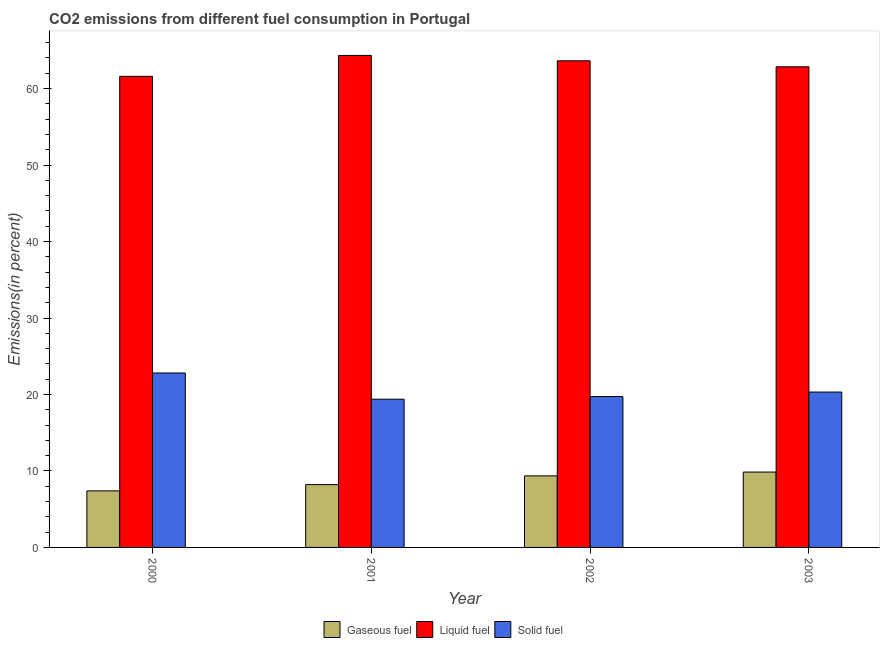How many groups of bars are there?
Offer a very short reply. 4. Are the number of bars per tick equal to the number of legend labels?
Your answer should be very brief. Yes. How many bars are there on the 3rd tick from the left?
Your answer should be compact. 3. In how many cases, is the number of bars for a given year not equal to the number of legend labels?
Your answer should be very brief. 0. What is the percentage of gaseous fuel emission in 2000?
Offer a terse response. 7.4. Across all years, what is the maximum percentage of liquid fuel emission?
Your answer should be very brief. 64.34. Across all years, what is the minimum percentage of liquid fuel emission?
Give a very brief answer. 61.6. What is the total percentage of solid fuel emission in the graph?
Give a very brief answer. 82.24. What is the difference between the percentage of gaseous fuel emission in 2001 and that in 2003?
Give a very brief answer. -1.64. What is the difference between the percentage of gaseous fuel emission in 2001 and the percentage of liquid fuel emission in 2002?
Your answer should be compact. -1.14. What is the average percentage of liquid fuel emission per year?
Provide a succinct answer. 63.1. In how many years, is the percentage of gaseous fuel emission greater than 28 %?
Provide a short and direct response. 0. What is the ratio of the percentage of gaseous fuel emission in 2001 to that in 2003?
Your answer should be very brief. 0.83. What is the difference between the highest and the second highest percentage of gaseous fuel emission?
Provide a short and direct response. 0.5. What is the difference between the highest and the lowest percentage of liquid fuel emission?
Your answer should be very brief. 2.74. Is the sum of the percentage of liquid fuel emission in 2000 and 2003 greater than the maximum percentage of gaseous fuel emission across all years?
Your answer should be very brief. Yes. What does the 3rd bar from the left in 2001 represents?
Offer a terse response. Solid fuel. What does the 1st bar from the right in 2002 represents?
Give a very brief answer. Solid fuel. Is it the case that in every year, the sum of the percentage of gaseous fuel emission and percentage of liquid fuel emission is greater than the percentage of solid fuel emission?
Your answer should be compact. Yes. How many bars are there?
Your response must be concise. 12. Are all the bars in the graph horizontal?
Offer a terse response. No. How many years are there in the graph?
Your answer should be very brief. 4. How are the legend labels stacked?
Offer a terse response. Horizontal. What is the title of the graph?
Your answer should be compact. CO2 emissions from different fuel consumption in Portugal. What is the label or title of the X-axis?
Your answer should be very brief. Year. What is the label or title of the Y-axis?
Provide a succinct answer. Emissions(in percent). What is the Emissions(in percent) of Gaseous fuel in 2000?
Give a very brief answer. 7.4. What is the Emissions(in percent) in Liquid fuel in 2000?
Offer a terse response. 61.6. What is the Emissions(in percent) of Solid fuel in 2000?
Ensure brevity in your answer.  22.81. What is the Emissions(in percent) in Gaseous fuel in 2001?
Give a very brief answer. 8.21. What is the Emissions(in percent) of Liquid fuel in 2001?
Ensure brevity in your answer.  64.34. What is the Emissions(in percent) of Solid fuel in 2001?
Make the answer very short. 19.38. What is the Emissions(in percent) in Gaseous fuel in 2002?
Your answer should be very brief. 9.36. What is the Emissions(in percent) of Liquid fuel in 2002?
Provide a succinct answer. 63.63. What is the Emissions(in percent) of Solid fuel in 2002?
Provide a short and direct response. 19.73. What is the Emissions(in percent) in Gaseous fuel in 2003?
Your answer should be compact. 9.86. What is the Emissions(in percent) in Liquid fuel in 2003?
Ensure brevity in your answer.  62.85. What is the Emissions(in percent) of Solid fuel in 2003?
Your response must be concise. 20.32. Across all years, what is the maximum Emissions(in percent) of Gaseous fuel?
Provide a succinct answer. 9.86. Across all years, what is the maximum Emissions(in percent) in Liquid fuel?
Give a very brief answer. 64.34. Across all years, what is the maximum Emissions(in percent) of Solid fuel?
Provide a short and direct response. 22.81. Across all years, what is the minimum Emissions(in percent) in Gaseous fuel?
Your answer should be compact. 7.4. Across all years, what is the minimum Emissions(in percent) of Liquid fuel?
Your answer should be compact. 61.6. Across all years, what is the minimum Emissions(in percent) of Solid fuel?
Keep it short and to the point. 19.38. What is the total Emissions(in percent) of Gaseous fuel in the graph?
Ensure brevity in your answer.  34.82. What is the total Emissions(in percent) in Liquid fuel in the graph?
Offer a very short reply. 252.41. What is the total Emissions(in percent) of Solid fuel in the graph?
Provide a short and direct response. 82.24. What is the difference between the Emissions(in percent) in Gaseous fuel in 2000 and that in 2001?
Provide a succinct answer. -0.82. What is the difference between the Emissions(in percent) in Liquid fuel in 2000 and that in 2001?
Offer a very short reply. -2.74. What is the difference between the Emissions(in percent) in Solid fuel in 2000 and that in 2001?
Give a very brief answer. 3.43. What is the difference between the Emissions(in percent) of Gaseous fuel in 2000 and that in 2002?
Keep it short and to the point. -1.96. What is the difference between the Emissions(in percent) of Liquid fuel in 2000 and that in 2002?
Provide a short and direct response. -2.03. What is the difference between the Emissions(in percent) in Solid fuel in 2000 and that in 2002?
Offer a very short reply. 3.08. What is the difference between the Emissions(in percent) in Gaseous fuel in 2000 and that in 2003?
Offer a terse response. -2.46. What is the difference between the Emissions(in percent) of Liquid fuel in 2000 and that in 2003?
Provide a succinct answer. -1.25. What is the difference between the Emissions(in percent) of Solid fuel in 2000 and that in 2003?
Offer a very short reply. 2.49. What is the difference between the Emissions(in percent) of Gaseous fuel in 2001 and that in 2002?
Give a very brief answer. -1.14. What is the difference between the Emissions(in percent) of Liquid fuel in 2001 and that in 2002?
Offer a terse response. 0.7. What is the difference between the Emissions(in percent) in Solid fuel in 2001 and that in 2002?
Make the answer very short. -0.34. What is the difference between the Emissions(in percent) of Gaseous fuel in 2001 and that in 2003?
Your answer should be compact. -1.64. What is the difference between the Emissions(in percent) of Liquid fuel in 2001 and that in 2003?
Make the answer very short. 1.49. What is the difference between the Emissions(in percent) of Solid fuel in 2001 and that in 2003?
Give a very brief answer. -0.93. What is the difference between the Emissions(in percent) in Gaseous fuel in 2002 and that in 2003?
Ensure brevity in your answer.  -0.5. What is the difference between the Emissions(in percent) in Liquid fuel in 2002 and that in 2003?
Ensure brevity in your answer.  0.78. What is the difference between the Emissions(in percent) of Solid fuel in 2002 and that in 2003?
Provide a succinct answer. -0.59. What is the difference between the Emissions(in percent) of Gaseous fuel in 2000 and the Emissions(in percent) of Liquid fuel in 2001?
Your response must be concise. -56.94. What is the difference between the Emissions(in percent) in Gaseous fuel in 2000 and the Emissions(in percent) in Solid fuel in 2001?
Offer a very short reply. -11.99. What is the difference between the Emissions(in percent) in Liquid fuel in 2000 and the Emissions(in percent) in Solid fuel in 2001?
Provide a succinct answer. 42.21. What is the difference between the Emissions(in percent) of Gaseous fuel in 2000 and the Emissions(in percent) of Liquid fuel in 2002?
Your response must be concise. -56.24. What is the difference between the Emissions(in percent) in Gaseous fuel in 2000 and the Emissions(in percent) in Solid fuel in 2002?
Offer a terse response. -12.33. What is the difference between the Emissions(in percent) in Liquid fuel in 2000 and the Emissions(in percent) in Solid fuel in 2002?
Ensure brevity in your answer.  41.87. What is the difference between the Emissions(in percent) in Gaseous fuel in 2000 and the Emissions(in percent) in Liquid fuel in 2003?
Provide a succinct answer. -55.45. What is the difference between the Emissions(in percent) in Gaseous fuel in 2000 and the Emissions(in percent) in Solid fuel in 2003?
Your answer should be very brief. -12.92. What is the difference between the Emissions(in percent) of Liquid fuel in 2000 and the Emissions(in percent) of Solid fuel in 2003?
Offer a terse response. 41.28. What is the difference between the Emissions(in percent) of Gaseous fuel in 2001 and the Emissions(in percent) of Liquid fuel in 2002?
Your answer should be compact. -55.42. What is the difference between the Emissions(in percent) in Gaseous fuel in 2001 and the Emissions(in percent) in Solid fuel in 2002?
Offer a very short reply. -11.52. What is the difference between the Emissions(in percent) in Liquid fuel in 2001 and the Emissions(in percent) in Solid fuel in 2002?
Your answer should be very brief. 44.61. What is the difference between the Emissions(in percent) of Gaseous fuel in 2001 and the Emissions(in percent) of Liquid fuel in 2003?
Your answer should be compact. -54.64. What is the difference between the Emissions(in percent) in Gaseous fuel in 2001 and the Emissions(in percent) in Solid fuel in 2003?
Your answer should be compact. -12.1. What is the difference between the Emissions(in percent) in Liquid fuel in 2001 and the Emissions(in percent) in Solid fuel in 2003?
Provide a succinct answer. 44.02. What is the difference between the Emissions(in percent) in Gaseous fuel in 2002 and the Emissions(in percent) in Liquid fuel in 2003?
Your response must be concise. -53.49. What is the difference between the Emissions(in percent) in Gaseous fuel in 2002 and the Emissions(in percent) in Solid fuel in 2003?
Ensure brevity in your answer.  -10.96. What is the difference between the Emissions(in percent) in Liquid fuel in 2002 and the Emissions(in percent) in Solid fuel in 2003?
Provide a succinct answer. 43.31. What is the average Emissions(in percent) in Gaseous fuel per year?
Your response must be concise. 8.71. What is the average Emissions(in percent) in Liquid fuel per year?
Offer a terse response. 63.1. What is the average Emissions(in percent) of Solid fuel per year?
Your answer should be compact. 20.56. In the year 2000, what is the difference between the Emissions(in percent) in Gaseous fuel and Emissions(in percent) in Liquid fuel?
Your response must be concise. -54.2. In the year 2000, what is the difference between the Emissions(in percent) of Gaseous fuel and Emissions(in percent) of Solid fuel?
Offer a terse response. -15.42. In the year 2000, what is the difference between the Emissions(in percent) of Liquid fuel and Emissions(in percent) of Solid fuel?
Provide a short and direct response. 38.79. In the year 2001, what is the difference between the Emissions(in percent) in Gaseous fuel and Emissions(in percent) in Liquid fuel?
Make the answer very short. -56.12. In the year 2001, what is the difference between the Emissions(in percent) in Gaseous fuel and Emissions(in percent) in Solid fuel?
Keep it short and to the point. -11.17. In the year 2001, what is the difference between the Emissions(in percent) in Liquid fuel and Emissions(in percent) in Solid fuel?
Your answer should be very brief. 44.95. In the year 2002, what is the difference between the Emissions(in percent) of Gaseous fuel and Emissions(in percent) of Liquid fuel?
Provide a short and direct response. -54.28. In the year 2002, what is the difference between the Emissions(in percent) in Gaseous fuel and Emissions(in percent) in Solid fuel?
Ensure brevity in your answer.  -10.37. In the year 2002, what is the difference between the Emissions(in percent) of Liquid fuel and Emissions(in percent) of Solid fuel?
Give a very brief answer. 43.9. In the year 2003, what is the difference between the Emissions(in percent) in Gaseous fuel and Emissions(in percent) in Liquid fuel?
Keep it short and to the point. -52.99. In the year 2003, what is the difference between the Emissions(in percent) of Gaseous fuel and Emissions(in percent) of Solid fuel?
Provide a succinct answer. -10.46. In the year 2003, what is the difference between the Emissions(in percent) of Liquid fuel and Emissions(in percent) of Solid fuel?
Provide a succinct answer. 42.53. What is the ratio of the Emissions(in percent) in Gaseous fuel in 2000 to that in 2001?
Keep it short and to the point. 0.9. What is the ratio of the Emissions(in percent) of Liquid fuel in 2000 to that in 2001?
Offer a very short reply. 0.96. What is the ratio of the Emissions(in percent) in Solid fuel in 2000 to that in 2001?
Offer a terse response. 1.18. What is the ratio of the Emissions(in percent) of Gaseous fuel in 2000 to that in 2002?
Provide a succinct answer. 0.79. What is the ratio of the Emissions(in percent) in Solid fuel in 2000 to that in 2002?
Provide a short and direct response. 1.16. What is the ratio of the Emissions(in percent) of Gaseous fuel in 2000 to that in 2003?
Provide a succinct answer. 0.75. What is the ratio of the Emissions(in percent) in Liquid fuel in 2000 to that in 2003?
Give a very brief answer. 0.98. What is the ratio of the Emissions(in percent) of Solid fuel in 2000 to that in 2003?
Provide a succinct answer. 1.12. What is the ratio of the Emissions(in percent) in Gaseous fuel in 2001 to that in 2002?
Your response must be concise. 0.88. What is the ratio of the Emissions(in percent) of Liquid fuel in 2001 to that in 2002?
Make the answer very short. 1.01. What is the ratio of the Emissions(in percent) in Solid fuel in 2001 to that in 2002?
Ensure brevity in your answer.  0.98. What is the ratio of the Emissions(in percent) of Liquid fuel in 2001 to that in 2003?
Your answer should be compact. 1.02. What is the ratio of the Emissions(in percent) in Solid fuel in 2001 to that in 2003?
Provide a short and direct response. 0.95. What is the ratio of the Emissions(in percent) of Gaseous fuel in 2002 to that in 2003?
Provide a short and direct response. 0.95. What is the ratio of the Emissions(in percent) of Liquid fuel in 2002 to that in 2003?
Give a very brief answer. 1.01. What is the ratio of the Emissions(in percent) of Solid fuel in 2002 to that in 2003?
Provide a short and direct response. 0.97. What is the difference between the highest and the second highest Emissions(in percent) of Gaseous fuel?
Provide a succinct answer. 0.5. What is the difference between the highest and the second highest Emissions(in percent) in Liquid fuel?
Make the answer very short. 0.7. What is the difference between the highest and the second highest Emissions(in percent) in Solid fuel?
Offer a terse response. 2.49. What is the difference between the highest and the lowest Emissions(in percent) in Gaseous fuel?
Give a very brief answer. 2.46. What is the difference between the highest and the lowest Emissions(in percent) of Liquid fuel?
Ensure brevity in your answer.  2.74. What is the difference between the highest and the lowest Emissions(in percent) of Solid fuel?
Your answer should be compact. 3.43. 